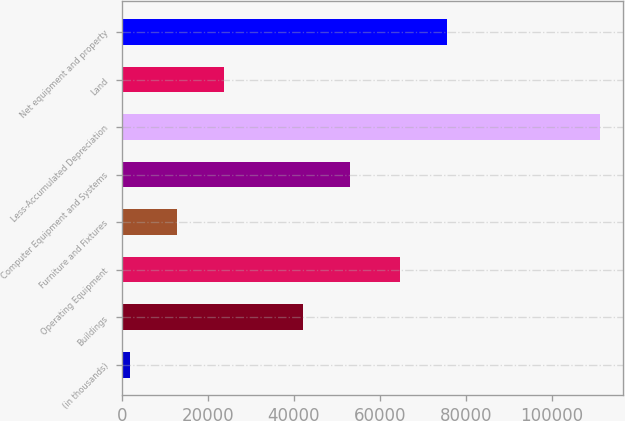Convert chart to OTSL. <chart><loc_0><loc_0><loc_500><loc_500><bar_chart><fcel>(in thousands)<fcel>Buildings<fcel>Operating Equipment<fcel>Furniture and Fixtures<fcel>Computer Equipment and Systems<fcel>Less-Accumulated Depreciation<fcel>Land<fcel>Net equipment and property<nl><fcel>2009<fcel>42230<fcel>64679<fcel>12917.6<fcel>53138.6<fcel>111095<fcel>23826.2<fcel>75587.6<nl></chart> 